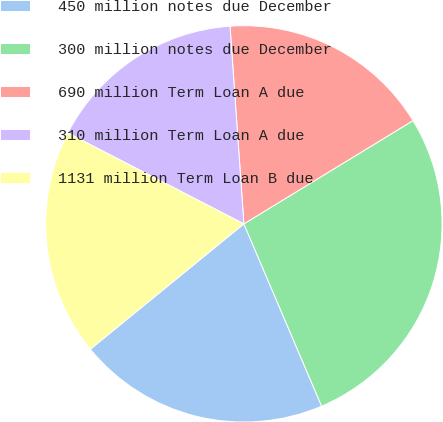<chart> <loc_0><loc_0><loc_500><loc_500><pie_chart><fcel>450 million notes due December<fcel>300 million notes due December<fcel>690 million Term Loan A due<fcel>310 million Term Loan A due<fcel>1131 million Term Loan B due<nl><fcel>20.52%<fcel>27.31%<fcel>17.39%<fcel>16.3%<fcel>18.48%<nl></chart> 